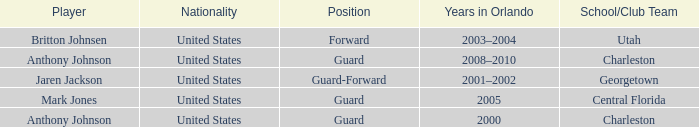Who was the Player that had the Position, guard-forward? Jaren Jackson. Parse the table in full. {'header': ['Player', 'Nationality', 'Position', 'Years in Orlando', 'School/Club Team'], 'rows': [['Britton Johnsen', 'United States', 'Forward', '2003–2004', 'Utah'], ['Anthony Johnson', 'United States', 'Guard', '2008–2010', 'Charleston'], ['Jaren Jackson', 'United States', 'Guard-Forward', '2001–2002', 'Georgetown'], ['Mark Jones', 'United States', 'Guard', '2005', 'Central Florida'], ['Anthony Johnson', 'United States', 'Guard', '2000', 'Charleston']]} 